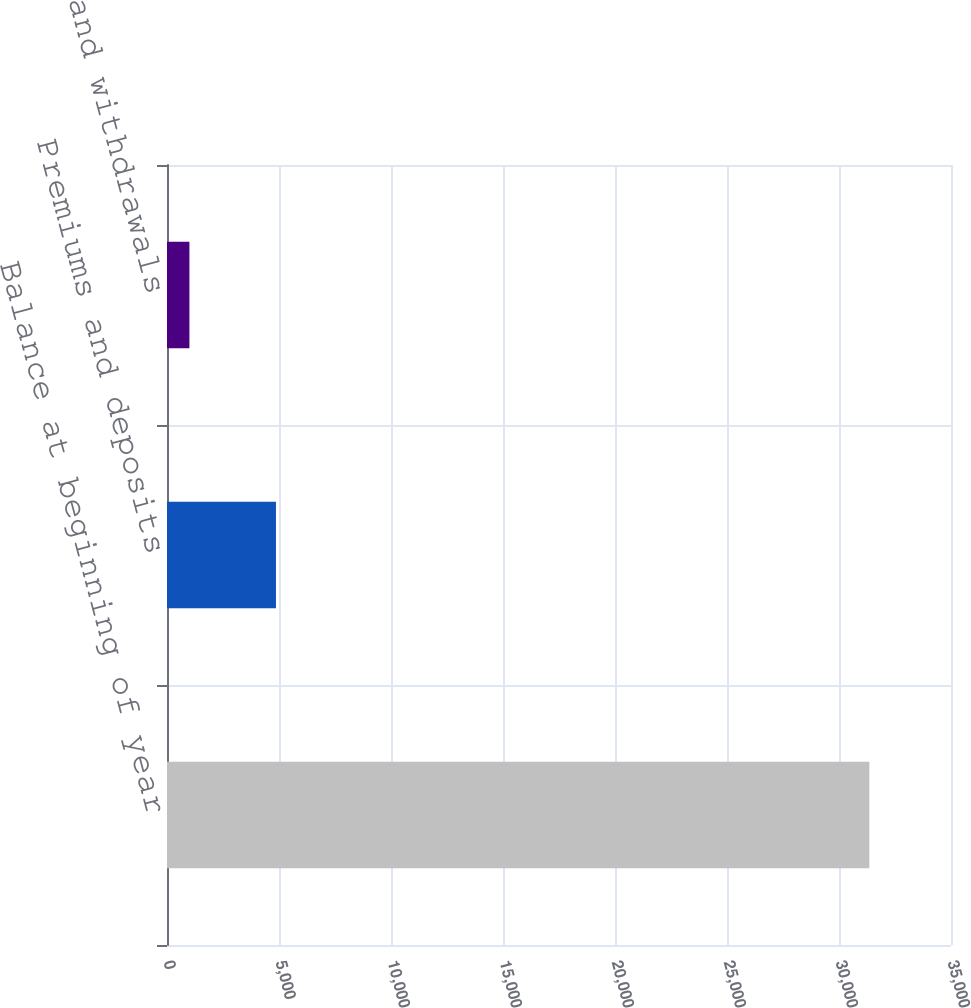<chart> <loc_0><loc_0><loc_500><loc_500><bar_chart><fcel>Balance at beginning of year<fcel>Premiums and deposits<fcel>Surrenders and withdrawals<nl><fcel>31354<fcel>4864<fcel>1001<nl></chart> 